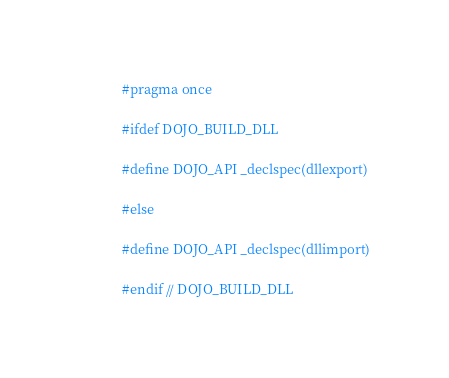Convert code to text. <code><loc_0><loc_0><loc_500><loc_500><_C_>#pragma once

#ifdef DOJO_BUILD_DLL

#define DOJO_API _declspec(dllexport)

#else

#define DOJO_API _declspec(dllimport)

#endif // DOJO_BUILD_DLL
</code> 